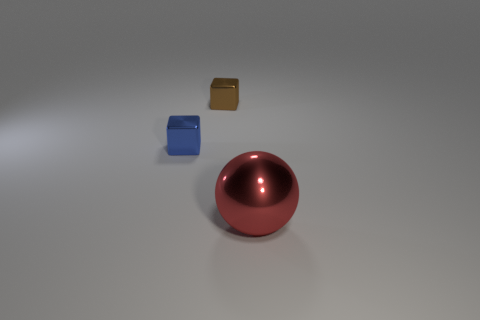Add 3 blue cubes. How many objects exist? 6 Subtract all cubes. How many objects are left? 1 Add 1 tiny things. How many tiny things exist? 3 Subtract 0 red cubes. How many objects are left? 3 Subtract all red metallic objects. Subtract all big things. How many objects are left? 1 Add 2 red shiny spheres. How many red shiny spheres are left? 3 